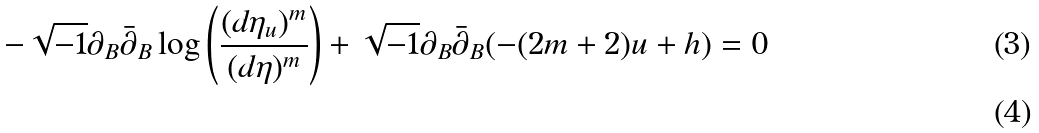<formula> <loc_0><loc_0><loc_500><loc_500>- \sqrt { - 1 } \partial _ { B } \bar { \partial } _ { B } \log \left ( \frac { ( d \eta _ { u } ) ^ { m } } { ( d \eta ) ^ { m } } \right ) + \sqrt { - 1 } \partial _ { B } \bar { \partial } _ { B } ( - ( 2 m + 2 ) u + h ) = 0 \\</formula> 